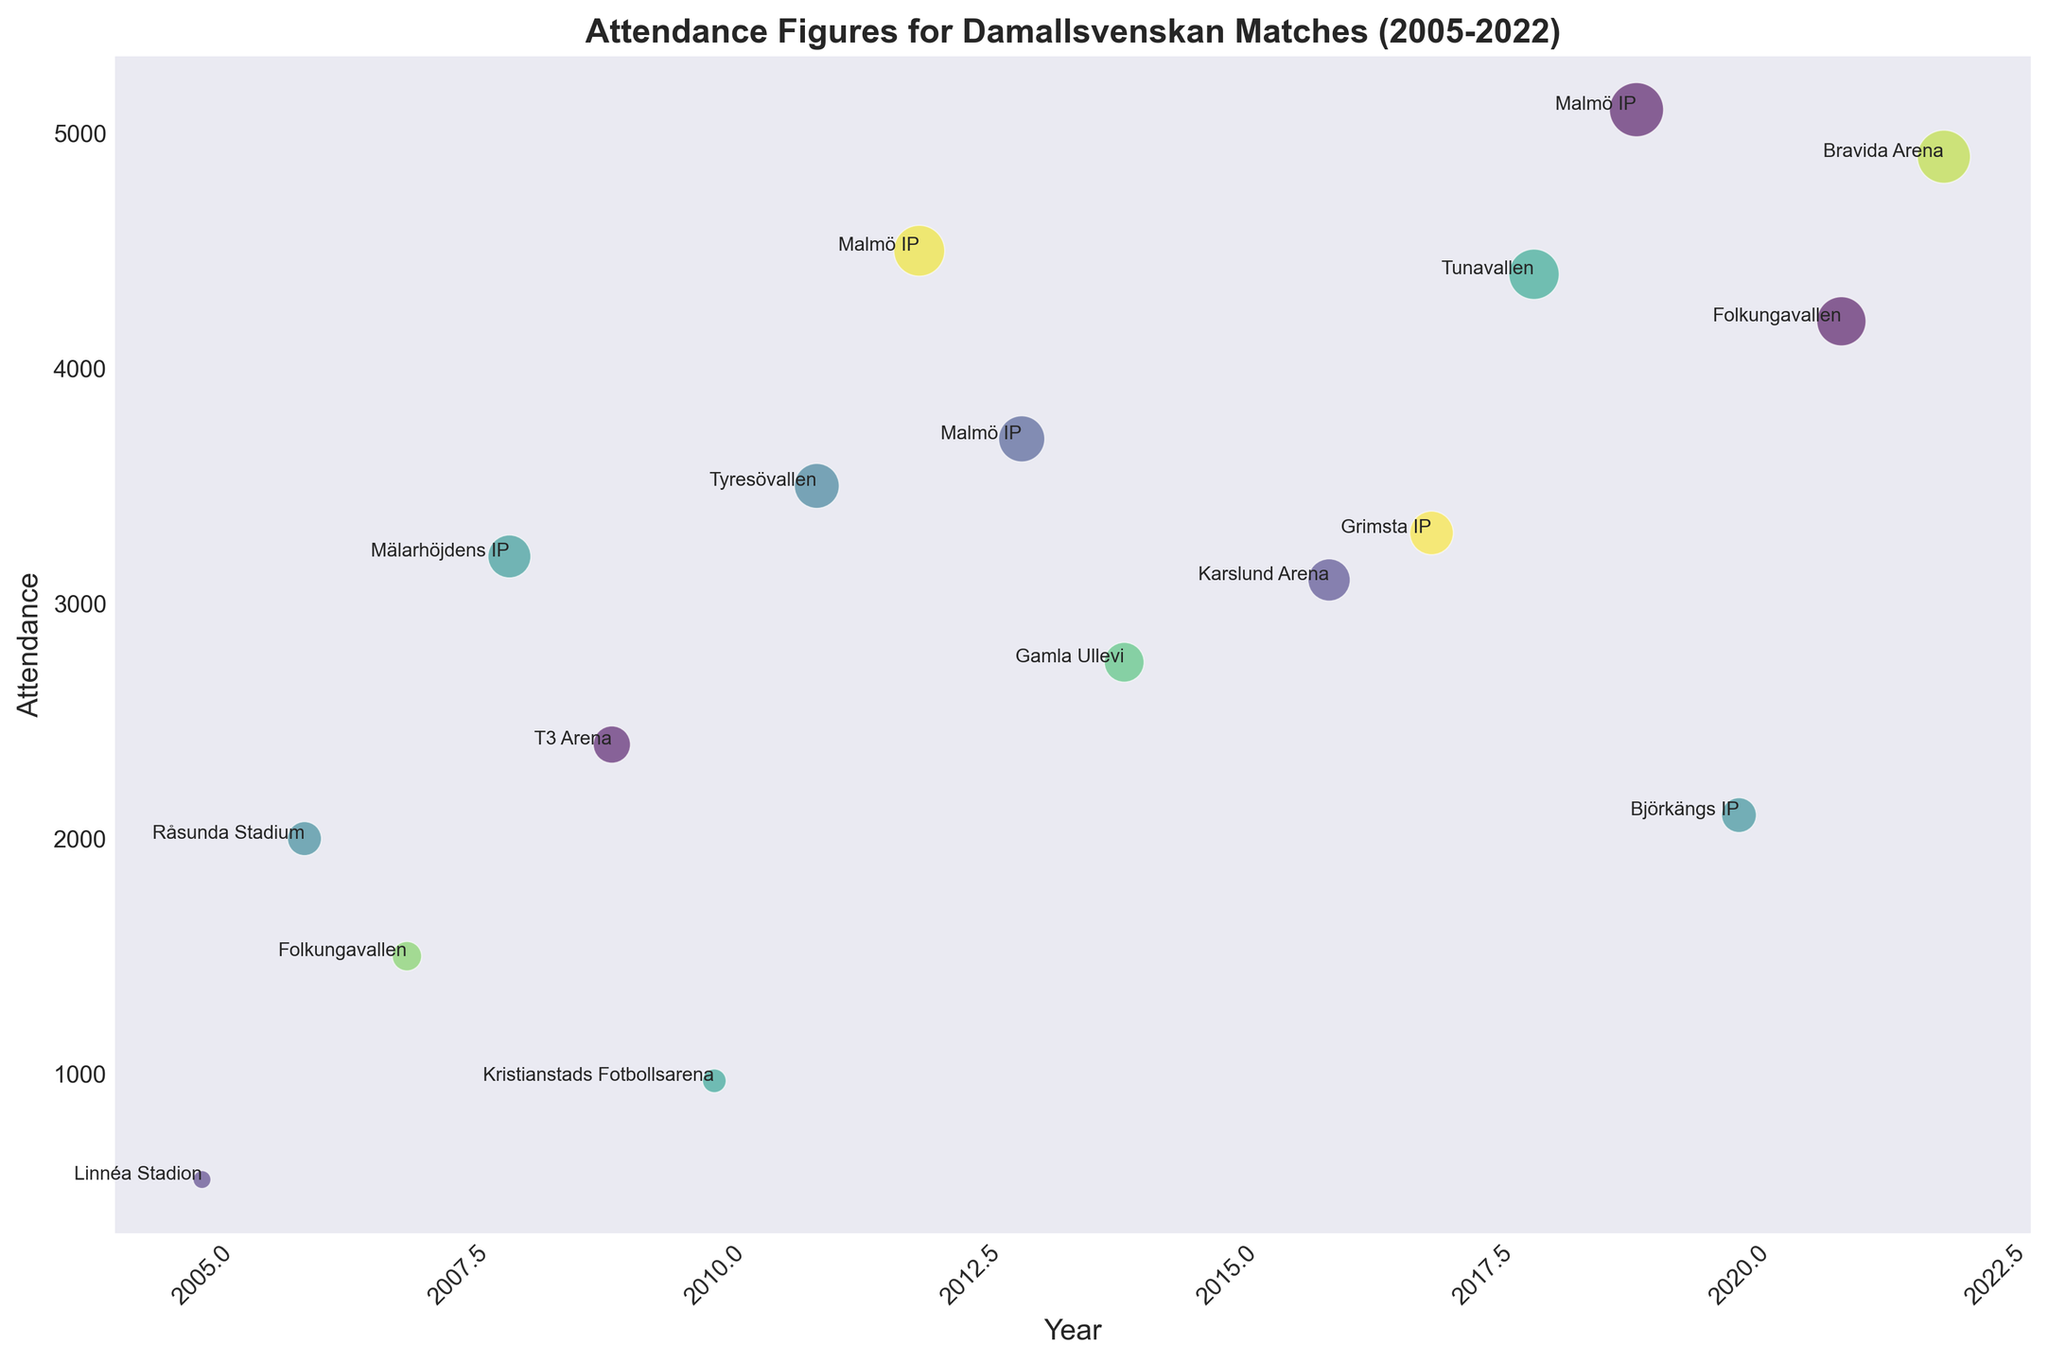Which year has the highest attendance figure for a Damallsvenskan match shown in the figure? By scanning the data points, the highest attendance figure can be identified, which is 5100 in the year 2019.
Answer: 2019 What’s the average attendance of matches held in Malmö? There are three matches in Malmö (2012, 2013, and 2019) with attendance figures of 4500, 3700, and 5100 respectively. The average attendance is calculated as (4500 + 3700 + 5100) / 3 = 4433.3.
Answer: 4433.3 Between the matches held in Folkungavallen, which year had the higher attendance? There are two matches held in Folkungavallen in 2007 and 2021 with attendance figures of 1500 and 4200 respectively. The match in 2021 had a higher attendance.
Answer: 2021 How does the attendance of matches at Tyresövallen compare to that of Björkängs IP? Tyresövallen had an attendance of 3500 in 2011, and Björkängs IP had an attendance of 2100 in 2020. Therefore, Tyresövallen had higher attendance.
Answer: Tyresövallen What is the total attendance for matches held in May across all the years? The attendance figures for May are: 550 (2005), 3200 (2008), 3100 (2016). Summing these gives 550 + 3200 + 3100 = 6850.
Answer: 6850 Which city had matches with attendance figures above 4000? Attendance figures above 4000 are in Malmö (2012: 4500, 2013: 3700, 2019: 5100), Eskilstuna (2018: 4400), and Linköping (2021: 4200).
Answer: Malmö, Eskilstuna, Linköping What is the minimum attendance figure recorded in the entire dataset? Scanning the figure, the smallest attendance figure is 550 recorded in 2005.
Answer: 550 Compare the attendance of the match held in 2008 to the one held in 2017. Which had a higher attendance and by how much? The attendance in 2008 (Hammarby IF DFF vs. LdB FC Malmö) was 3200 and in 2017 (Hammarby IF DFF vs. Kristianstads DFF) was 3300. The 2017 match had a higher attendance by 3300 - 3200 = 100.
Answer: 2017, by 100 What is the difference in attendance between the matches held in 2012 and 2013 in Malmö IP? The attendance in 2012 was 4500, and in 2013 it was 3700. The difference is 4500 - 3700 = 800.
Answer: 800 Which city consistently hosted matches with high attendance figures (above 3000) based on the given years? Analyzing the cities with high attendance figures repeatedly: Malmö hosted matches with attendance figures of 4500 (2012), 3700 (2013), and 5100 (2019), thus consistently high.
Answer: Malmö 